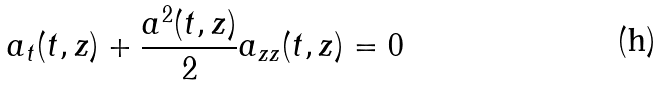<formula> <loc_0><loc_0><loc_500><loc_500>a _ { t } ( t , z ) + \frac { a ^ { 2 } ( t , z ) } { 2 } a _ { z z } ( t , z ) = 0</formula> 